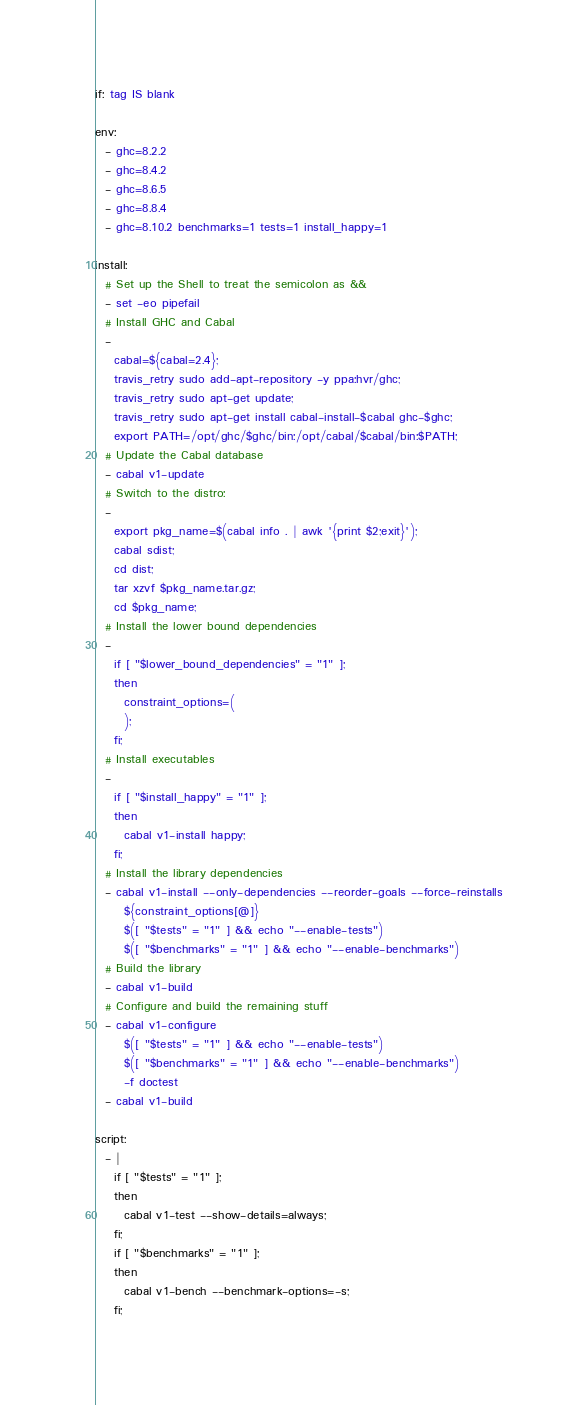<code> <loc_0><loc_0><loc_500><loc_500><_YAML_>if: tag IS blank

env:
  - ghc=8.2.2
  - ghc=8.4.2
  - ghc=8.6.5
  - ghc=8.8.4
  - ghc=8.10.2 benchmarks=1 tests=1 install_happy=1

install:
  # Set up the Shell to treat the semicolon as &&
  - set -eo pipefail
  # Install GHC and Cabal
  -
    cabal=${cabal=2.4};
    travis_retry sudo add-apt-repository -y ppa:hvr/ghc;
    travis_retry sudo apt-get update;
    travis_retry sudo apt-get install cabal-install-$cabal ghc-$ghc;
    export PATH=/opt/ghc/$ghc/bin:/opt/cabal/$cabal/bin:$PATH;
  # Update the Cabal database
  - cabal v1-update
  # Switch to the distro:
  - 
    export pkg_name=$(cabal info . | awk '{print $2;exit}');
    cabal sdist;
    cd dist;
    tar xzvf $pkg_name.tar.gz;
    cd $pkg_name;
  # Install the lower bound dependencies
  - 
    if [ "$lower_bound_dependencies" = "1" ];
    then
      constraint_options=(
      );
    fi;
  # Install executables
  -
    if [ "$install_happy" = "1" ];
    then
      cabal v1-install happy;
    fi;
  # Install the library dependencies
  - cabal v1-install --only-dependencies --reorder-goals --force-reinstalls
      ${constraint_options[@]}
      $([ "$tests" = "1" ] && echo "--enable-tests")
      $([ "$benchmarks" = "1" ] && echo "--enable-benchmarks")
  # Build the library
  - cabal v1-build
  # Configure and build the remaining stuff
  - cabal v1-configure 
      $([ "$tests" = "1" ] && echo "--enable-tests")
      $([ "$benchmarks" = "1" ] && echo "--enable-benchmarks")
      -f doctest
  - cabal v1-build

script:
  - |
    if [ "$tests" = "1" ];
    then
      cabal v1-test --show-details=always;
    fi;
    if [ "$benchmarks" = "1" ];
    then
      cabal v1-bench --benchmark-options=-s;
    fi;
</code> 